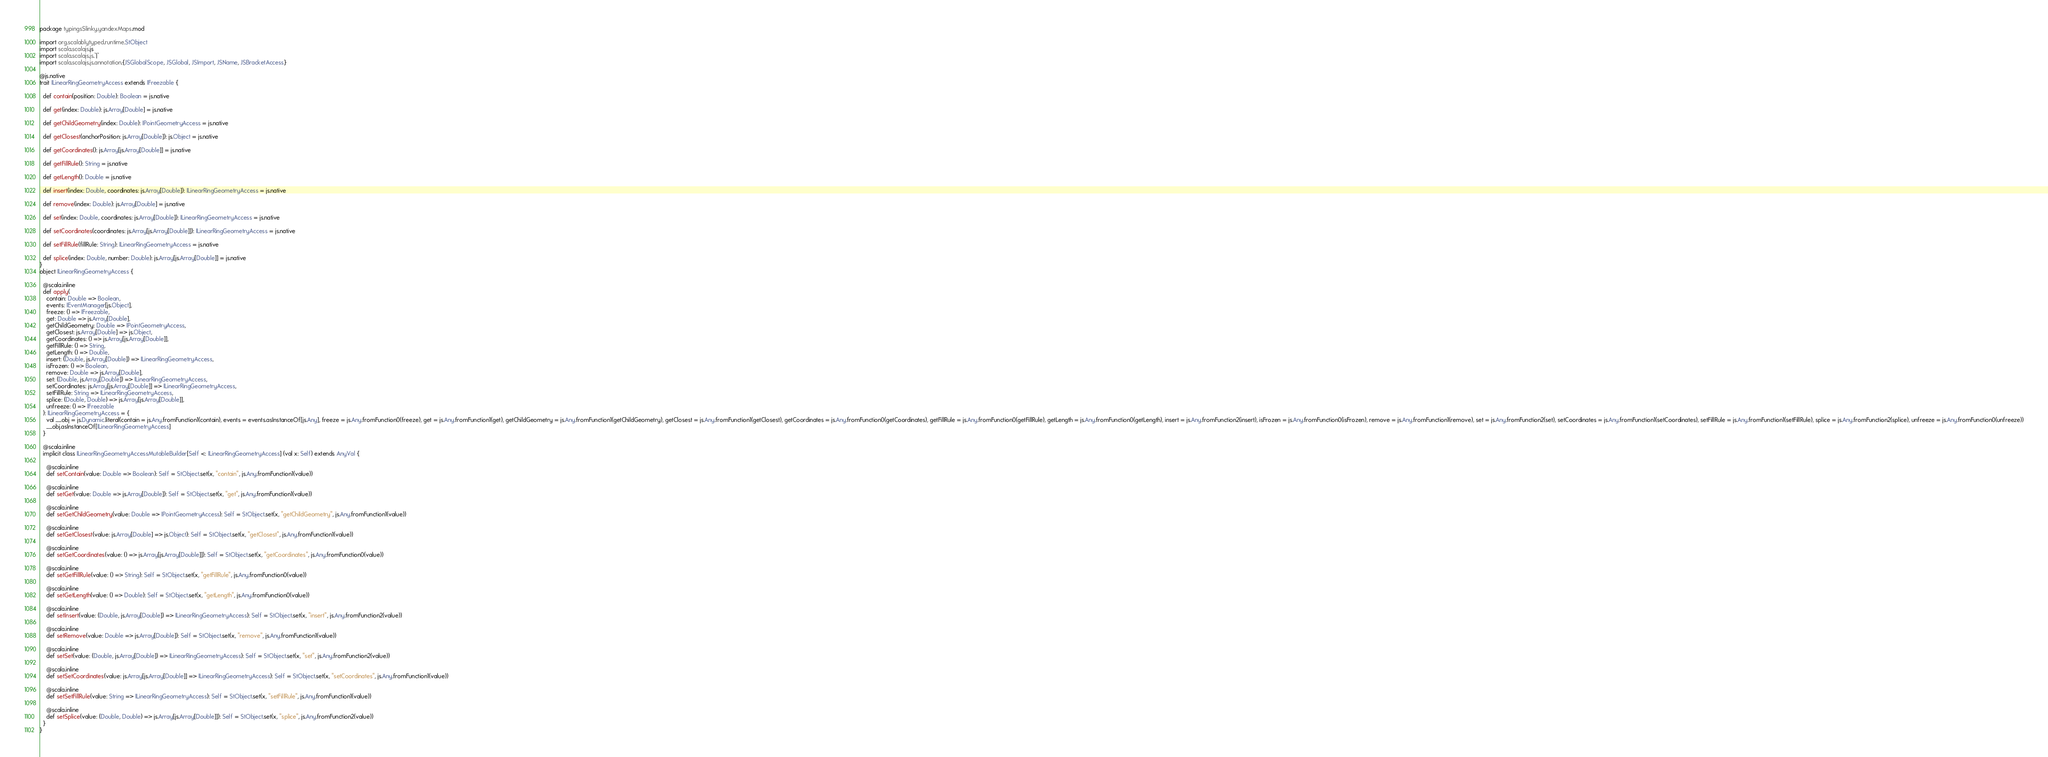Convert code to text. <code><loc_0><loc_0><loc_500><loc_500><_Scala_>package typingsSlinky.yandexMaps.mod

import org.scalablytyped.runtime.StObject
import scala.scalajs.js
import scala.scalajs.js.`|`
import scala.scalajs.js.annotation.{JSGlobalScope, JSGlobal, JSImport, JSName, JSBracketAccess}

@js.native
trait ILinearRingGeometryAccess extends IFreezable {
  
  def contain(position: Double): Boolean = js.native
  
  def get(index: Double): js.Array[Double] = js.native
  
  def getChildGeometry(index: Double): IPointGeometryAccess = js.native
  
  def getClosest(anchorPosition: js.Array[Double]): js.Object = js.native
  
  def getCoordinates(): js.Array[js.Array[Double]] = js.native
  
  def getFillRule(): String = js.native
  
  def getLength(): Double = js.native
  
  def insert(index: Double, coordinates: js.Array[Double]): ILinearRingGeometryAccess = js.native
  
  def remove(index: Double): js.Array[Double] = js.native
  
  def set(index: Double, coordinates: js.Array[Double]): ILinearRingGeometryAccess = js.native
  
  def setCoordinates(coordinates: js.Array[js.Array[Double]]): ILinearRingGeometryAccess = js.native
  
  def setFillRule(fillRule: String): ILinearRingGeometryAccess = js.native
  
  def splice(index: Double, number: Double): js.Array[js.Array[Double]] = js.native
}
object ILinearRingGeometryAccess {
  
  @scala.inline
  def apply(
    contain: Double => Boolean,
    events: IEventManager[js.Object],
    freeze: () => IFreezable,
    get: Double => js.Array[Double],
    getChildGeometry: Double => IPointGeometryAccess,
    getClosest: js.Array[Double] => js.Object,
    getCoordinates: () => js.Array[js.Array[Double]],
    getFillRule: () => String,
    getLength: () => Double,
    insert: (Double, js.Array[Double]) => ILinearRingGeometryAccess,
    isFrozen: () => Boolean,
    remove: Double => js.Array[Double],
    set: (Double, js.Array[Double]) => ILinearRingGeometryAccess,
    setCoordinates: js.Array[js.Array[Double]] => ILinearRingGeometryAccess,
    setFillRule: String => ILinearRingGeometryAccess,
    splice: (Double, Double) => js.Array[js.Array[Double]],
    unfreeze: () => IFreezable
  ): ILinearRingGeometryAccess = {
    val __obj = js.Dynamic.literal(contain = js.Any.fromFunction1(contain), events = events.asInstanceOf[js.Any], freeze = js.Any.fromFunction0(freeze), get = js.Any.fromFunction1(get), getChildGeometry = js.Any.fromFunction1(getChildGeometry), getClosest = js.Any.fromFunction1(getClosest), getCoordinates = js.Any.fromFunction0(getCoordinates), getFillRule = js.Any.fromFunction0(getFillRule), getLength = js.Any.fromFunction0(getLength), insert = js.Any.fromFunction2(insert), isFrozen = js.Any.fromFunction0(isFrozen), remove = js.Any.fromFunction1(remove), set = js.Any.fromFunction2(set), setCoordinates = js.Any.fromFunction1(setCoordinates), setFillRule = js.Any.fromFunction1(setFillRule), splice = js.Any.fromFunction2(splice), unfreeze = js.Any.fromFunction0(unfreeze))
    __obj.asInstanceOf[ILinearRingGeometryAccess]
  }
  
  @scala.inline
  implicit class ILinearRingGeometryAccessMutableBuilder[Self <: ILinearRingGeometryAccess] (val x: Self) extends AnyVal {
    
    @scala.inline
    def setContain(value: Double => Boolean): Self = StObject.set(x, "contain", js.Any.fromFunction1(value))
    
    @scala.inline
    def setGet(value: Double => js.Array[Double]): Self = StObject.set(x, "get", js.Any.fromFunction1(value))
    
    @scala.inline
    def setGetChildGeometry(value: Double => IPointGeometryAccess): Self = StObject.set(x, "getChildGeometry", js.Any.fromFunction1(value))
    
    @scala.inline
    def setGetClosest(value: js.Array[Double] => js.Object): Self = StObject.set(x, "getClosest", js.Any.fromFunction1(value))
    
    @scala.inline
    def setGetCoordinates(value: () => js.Array[js.Array[Double]]): Self = StObject.set(x, "getCoordinates", js.Any.fromFunction0(value))
    
    @scala.inline
    def setGetFillRule(value: () => String): Self = StObject.set(x, "getFillRule", js.Any.fromFunction0(value))
    
    @scala.inline
    def setGetLength(value: () => Double): Self = StObject.set(x, "getLength", js.Any.fromFunction0(value))
    
    @scala.inline
    def setInsert(value: (Double, js.Array[Double]) => ILinearRingGeometryAccess): Self = StObject.set(x, "insert", js.Any.fromFunction2(value))
    
    @scala.inline
    def setRemove(value: Double => js.Array[Double]): Self = StObject.set(x, "remove", js.Any.fromFunction1(value))
    
    @scala.inline
    def setSet(value: (Double, js.Array[Double]) => ILinearRingGeometryAccess): Self = StObject.set(x, "set", js.Any.fromFunction2(value))
    
    @scala.inline
    def setSetCoordinates(value: js.Array[js.Array[Double]] => ILinearRingGeometryAccess): Self = StObject.set(x, "setCoordinates", js.Any.fromFunction1(value))
    
    @scala.inline
    def setSetFillRule(value: String => ILinearRingGeometryAccess): Self = StObject.set(x, "setFillRule", js.Any.fromFunction1(value))
    
    @scala.inline
    def setSplice(value: (Double, Double) => js.Array[js.Array[Double]]): Self = StObject.set(x, "splice", js.Any.fromFunction2(value))
  }
}
</code> 